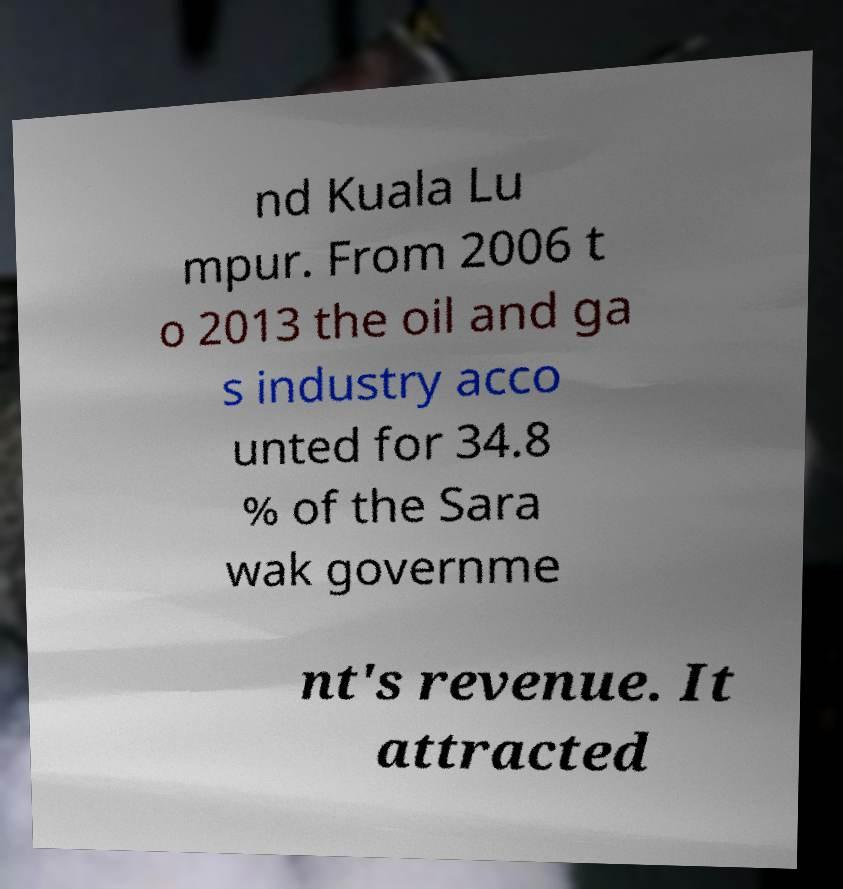What messages or text are displayed in this image? I need them in a readable, typed format. nd Kuala Lu mpur. From 2006 t o 2013 the oil and ga s industry acco unted for 34.8 % of the Sara wak governme nt's revenue. It attracted 